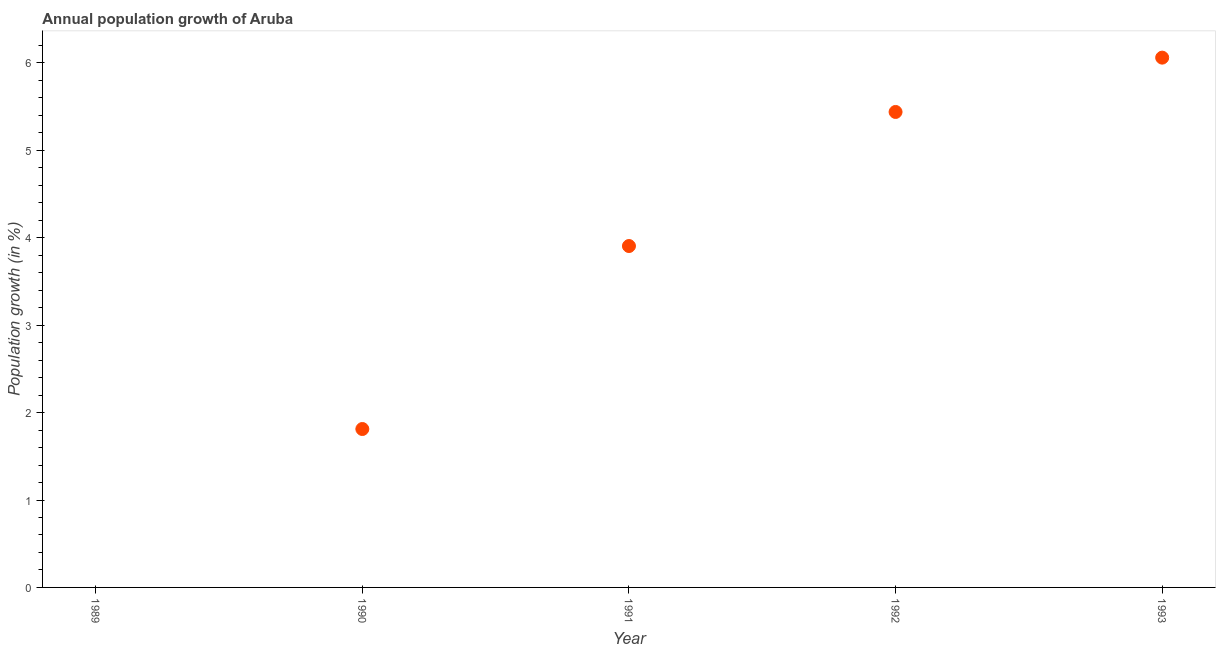What is the population growth in 1991?
Ensure brevity in your answer.  3.91. Across all years, what is the maximum population growth?
Keep it short and to the point. 6.06. What is the sum of the population growth?
Give a very brief answer. 17.22. What is the difference between the population growth in 1991 and 1993?
Your response must be concise. -2.15. What is the average population growth per year?
Offer a terse response. 3.44. What is the median population growth?
Make the answer very short. 3.91. What is the ratio of the population growth in 1991 to that in 1993?
Provide a succinct answer. 0.64. Is the population growth in 1991 less than that in 1993?
Offer a terse response. Yes. What is the difference between the highest and the second highest population growth?
Make the answer very short. 0.62. Is the sum of the population growth in 1990 and 1991 greater than the maximum population growth across all years?
Keep it short and to the point. No. What is the difference between the highest and the lowest population growth?
Give a very brief answer. 6.06. How many dotlines are there?
Your response must be concise. 1. What is the difference between two consecutive major ticks on the Y-axis?
Give a very brief answer. 1. Does the graph contain grids?
Your answer should be compact. No. What is the title of the graph?
Offer a very short reply. Annual population growth of Aruba. What is the label or title of the X-axis?
Provide a short and direct response. Year. What is the label or title of the Y-axis?
Keep it short and to the point. Population growth (in %). What is the Population growth (in %) in 1990?
Provide a succinct answer. 1.81. What is the Population growth (in %) in 1991?
Offer a terse response. 3.91. What is the Population growth (in %) in 1992?
Offer a very short reply. 5.44. What is the Population growth (in %) in 1993?
Offer a terse response. 6.06. What is the difference between the Population growth (in %) in 1990 and 1991?
Provide a short and direct response. -2.09. What is the difference between the Population growth (in %) in 1990 and 1992?
Give a very brief answer. -3.63. What is the difference between the Population growth (in %) in 1990 and 1993?
Your answer should be very brief. -4.25. What is the difference between the Population growth (in %) in 1991 and 1992?
Your response must be concise. -1.53. What is the difference between the Population growth (in %) in 1991 and 1993?
Your response must be concise. -2.15. What is the difference between the Population growth (in %) in 1992 and 1993?
Ensure brevity in your answer.  -0.62. What is the ratio of the Population growth (in %) in 1990 to that in 1991?
Offer a very short reply. 0.46. What is the ratio of the Population growth (in %) in 1990 to that in 1992?
Provide a short and direct response. 0.33. What is the ratio of the Population growth (in %) in 1990 to that in 1993?
Give a very brief answer. 0.3. What is the ratio of the Population growth (in %) in 1991 to that in 1992?
Give a very brief answer. 0.72. What is the ratio of the Population growth (in %) in 1991 to that in 1993?
Your answer should be very brief. 0.64. What is the ratio of the Population growth (in %) in 1992 to that in 1993?
Provide a succinct answer. 0.9. 